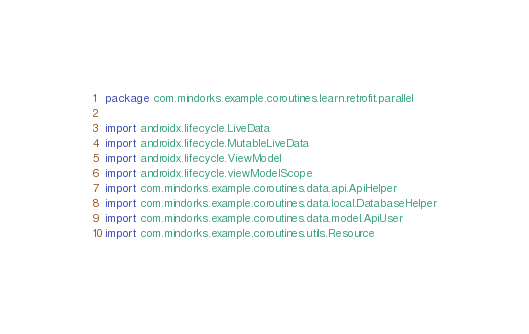<code> <loc_0><loc_0><loc_500><loc_500><_Kotlin_>package com.mindorks.example.coroutines.learn.retrofit.parallel

import androidx.lifecycle.LiveData
import androidx.lifecycle.MutableLiveData
import androidx.lifecycle.ViewModel
import androidx.lifecycle.viewModelScope
import com.mindorks.example.coroutines.data.api.ApiHelper
import com.mindorks.example.coroutines.data.local.DatabaseHelper
import com.mindorks.example.coroutines.data.model.ApiUser
import com.mindorks.example.coroutines.utils.Resource</code> 